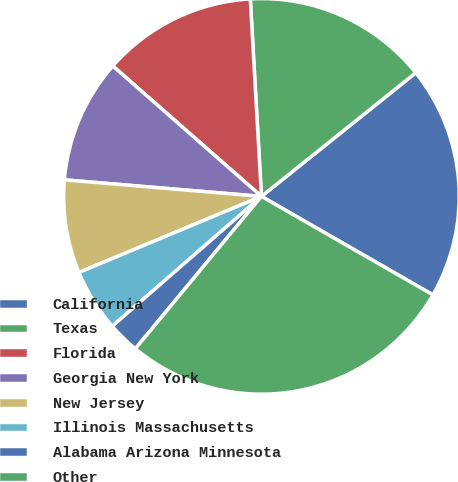Convert chart. <chart><loc_0><loc_0><loc_500><loc_500><pie_chart><fcel>California<fcel>Texas<fcel>Florida<fcel>Georgia New York<fcel>New Jersey<fcel>Illinois Massachusetts<fcel>Alabama Arizona Minnesota<fcel>Other<nl><fcel>19.05%<fcel>15.15%<fcel>12.64%<fcel>10.13%<fcel>7.62%<fcel>5.11%<fcel>2.6%<fcel>27.71%<nl></chart> 